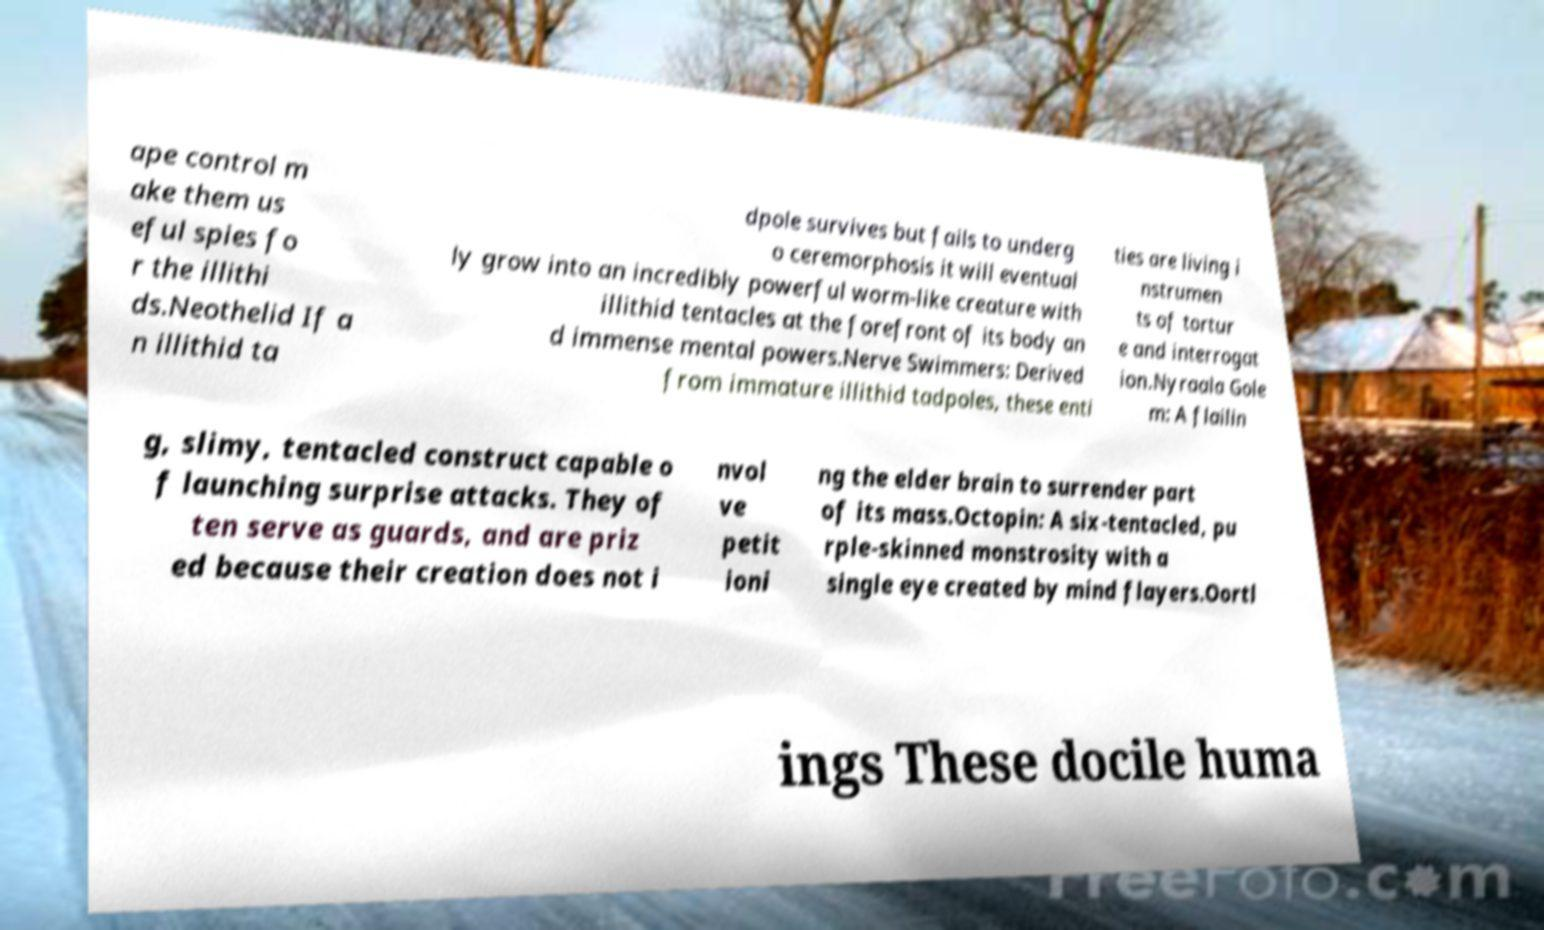I need the written content from this picture converted into text. Can you do that? ape control m ake them us eful spies fo r the illithi ds.Neothelid If a n illithid ta dpole survives but fails to underg o ceremorphosis it will eventual ly grow into an incredibly powerful worm-like creature with illithid tentacles at the forefront of its body an d immense mental powers.Nerve Swimmers: Derived from immature illithid tadpoles, these enti ties are living i nstrumen ts of tortur e and interrogat ion.Nyraala Gole m: A flailin g, slimy, tentacled construct capable o f launching surprise attacks. They of ten serve as guards, and are priz ed because their creation does not i nvol ve petit ioni ng the elder brain to surrender part of its mass.Octopin: A six-tentacled, pu rple-skinned monstrosity with a single eye created by mind flayers.Oortl ings These docile huma 